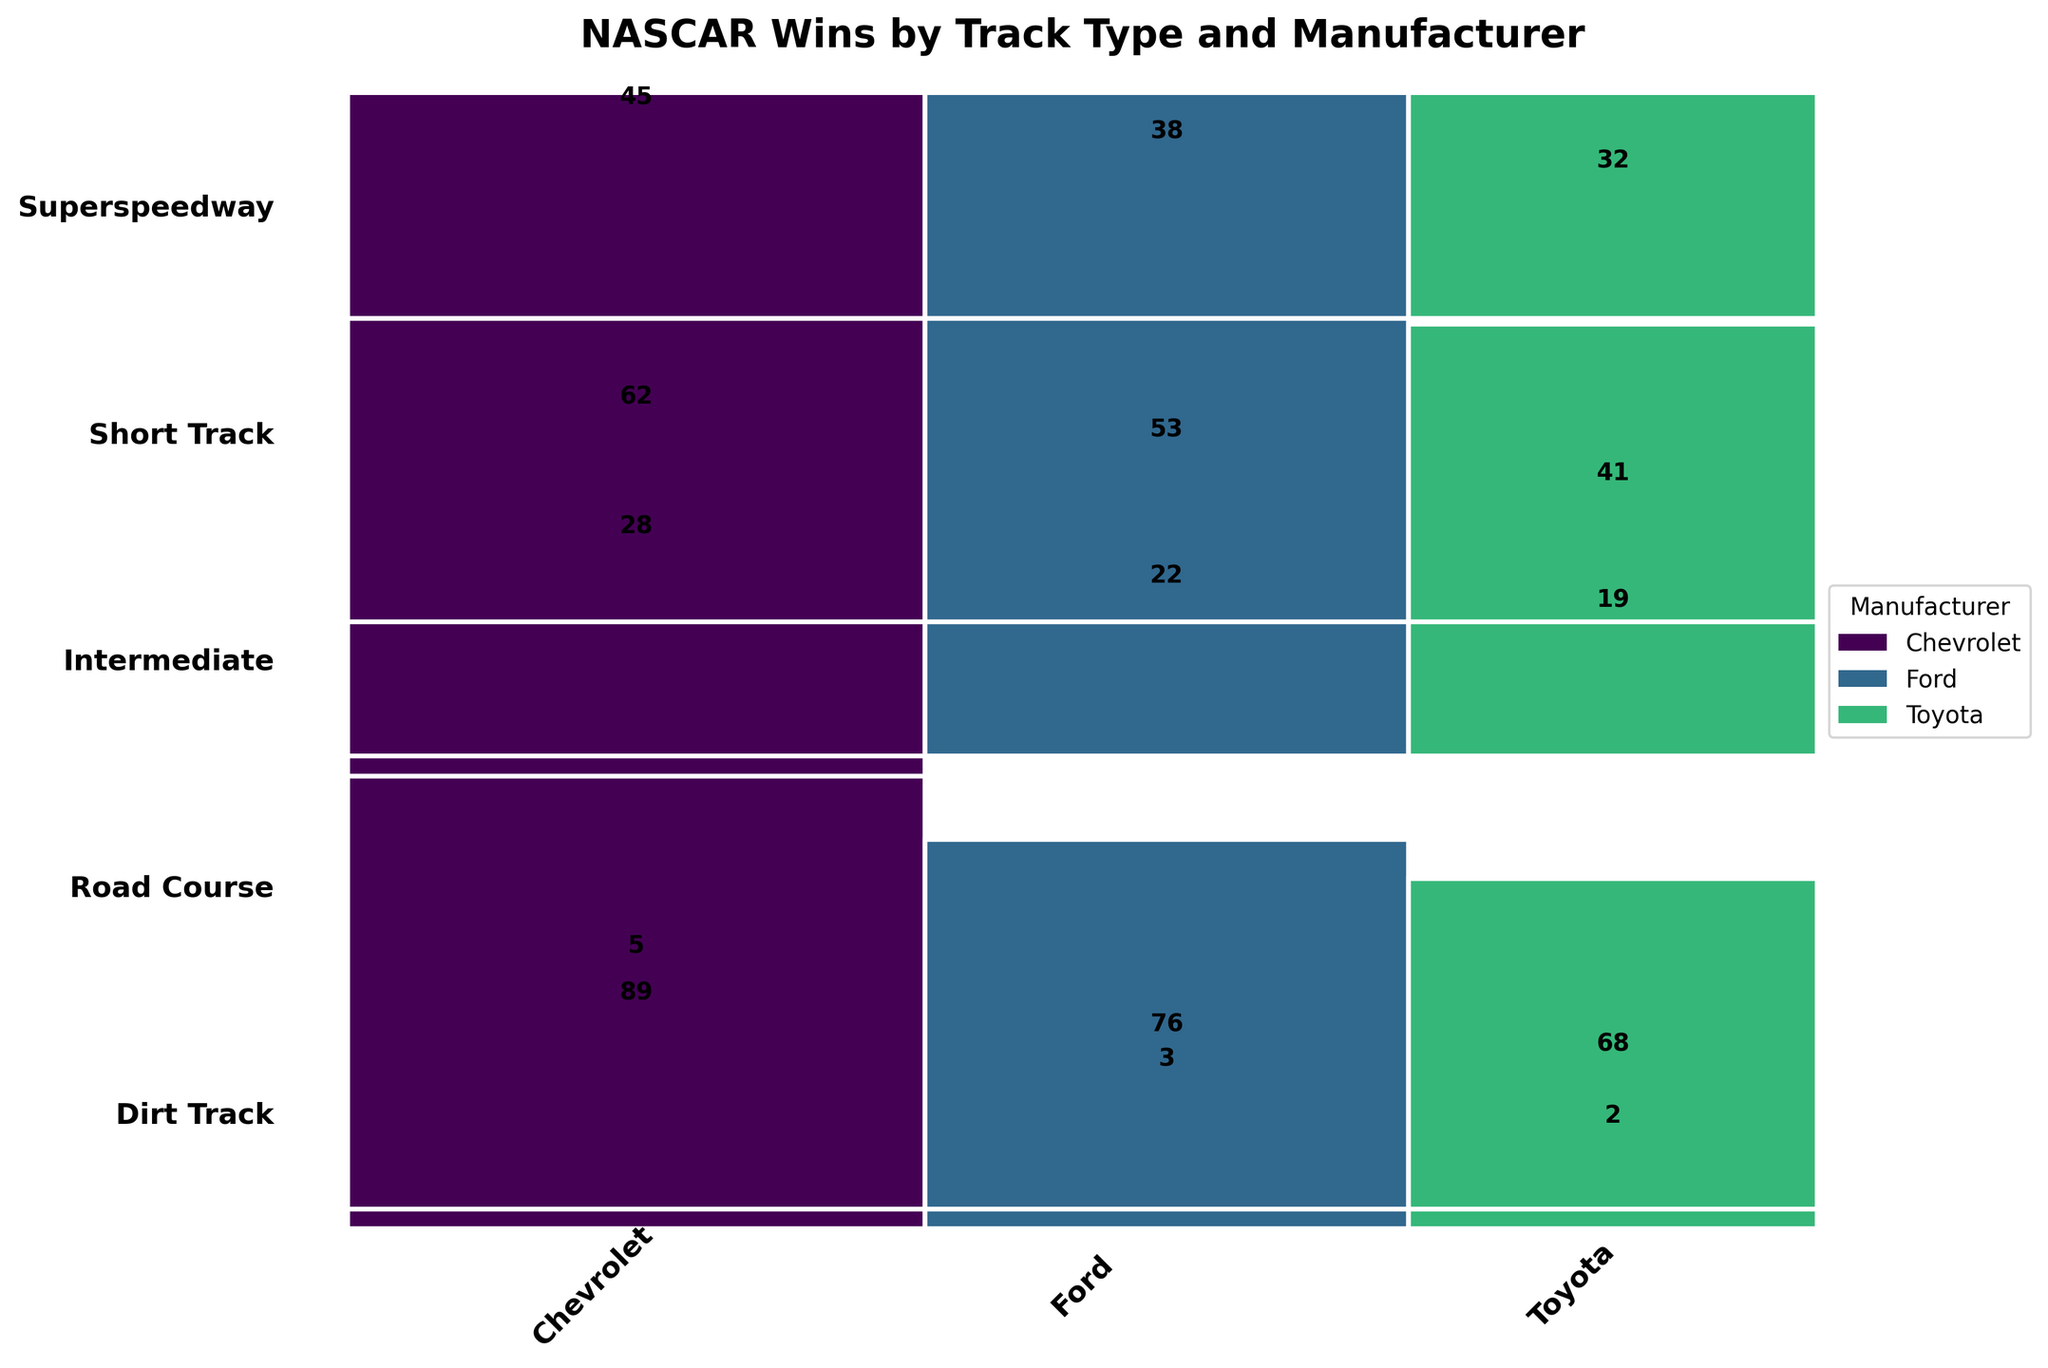What's the total number of wins represented in the figure? The figure represents the total wins by track type and manufacturer. By summing up all values: 45 + 38 + 32 + 62 + 53 + 41 + 89 + 76 + 68 + 28 + 22 + 19 + 5 + 3 + 2, the total is 583
Answer: 583 Which manufacturer has the most wins on short tracks? Look at the short track row and find the manufacturer with the most prominent block. Chevrolet’s block is the largest with 62 wins
Answer: Chevrolet Compare the total wins for Ford and Toyota. Which has more? Sum up the wins for Ford: 38 + 53 + 76 + 22 + 3 = 192. Sum up the wins for Toyota: 32 + 41 + 68 + 19 + 2 = 162. Ford has more wins
Answer: Ford How many more wins does Chevrolet have on intermediate tracks compared to Toyota on the same tracks? Chevrolet's wins on intermediate tracks: 89. Toyota's wins on intermediate tracks: 68. Subtract Toyota's wins from Chevrolet’s: 89 - 68 = 21
Answer: 21 Which track type has the fewest wins for Toyota? By comparing the wins for Toyota across all track types: Superspeedway (32), Short Track (41), Intermediate (68), Road Course (19), Dirt Track (2), the fewest wins are on Dirt Track
Answer: Dirt Track Is the proportion of Toyota’s wins on road courses higher than on superspeedways? Calculate the proportion of Toyota's wins: Road courses: 19/69 ≈ 0.275, Superspeedways: 32/115 ≈ 0.278. The road course proportion is slightly lower
Answer: No What is the total number of wins on dirt tracks? Sum the wins on dirt tracks for all manufacturers: 5 (Chevrolet) + 3 (Ford) + 2 (Toyota) = 10
Answer: 10 Which track type accounts for the largest total number of wins among all manufacturers? Check the sum for each track type: Superspeedway (115), Short Track (156), Intermediate (233), Road Course (69), Dirt Track (10). Intermediate has the most
Answer: Intermediate Does Chevrolet have more wins on intermediate tracks than the combined wins of Toyota across all tracks? Chevrolet on intermediate tracks: 89. Sum Toyota’s wins across all tracks: 32 + 41 + 68 + 19 + 2 = 162. 89 is less than 162
Answer: No Which track type has the highest concentration of wins for a single manufacturer? Inspect all rows to find the largest single block. On intermediate tracks, Chevrolet has 89 wins, which is the highest concentration in a single track type
Answer: Intermediate (Chevrolet) 